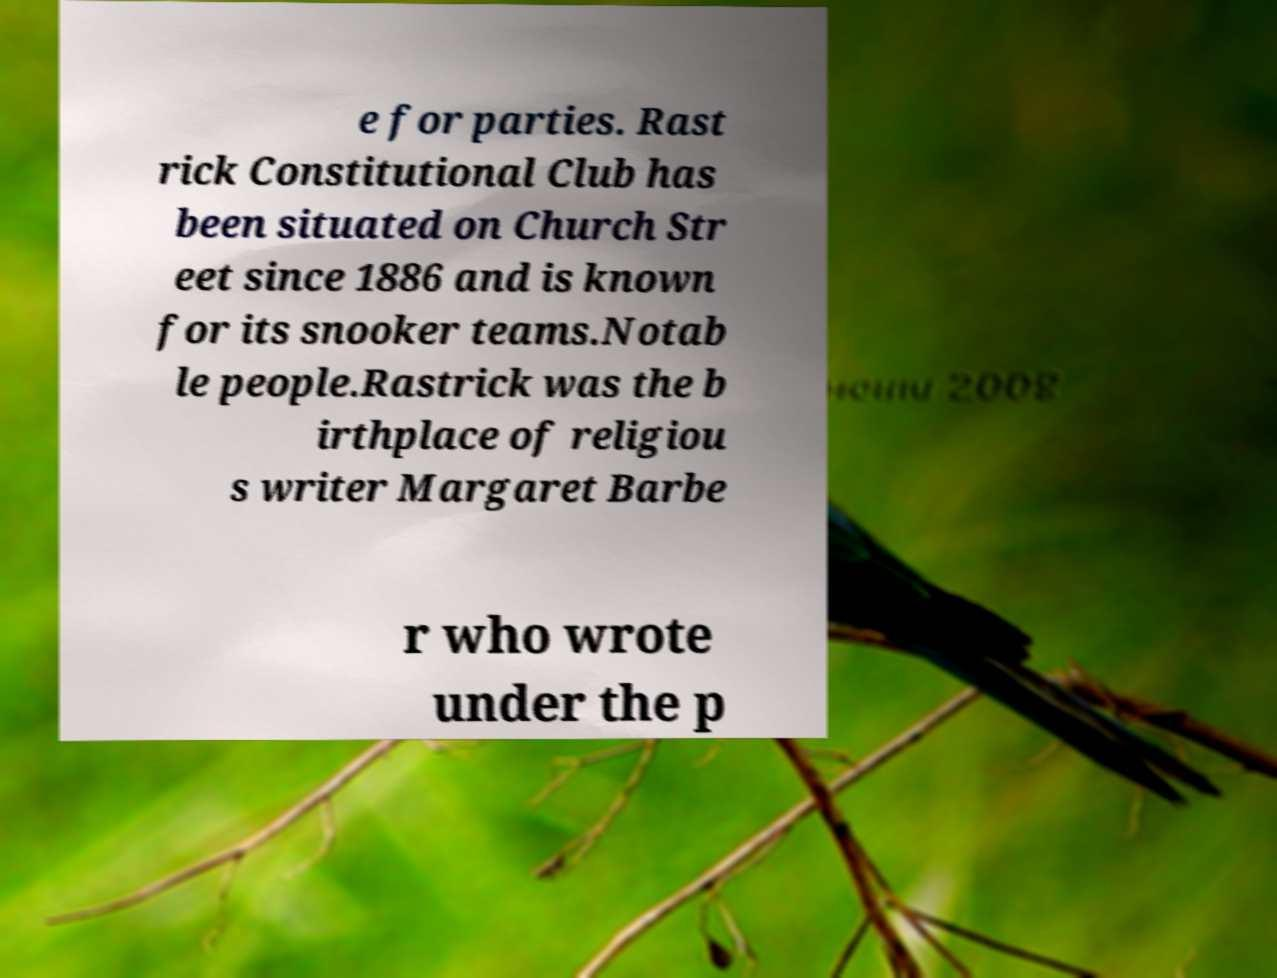Could you extract and type out the text from this image? e for parties. Rast rick Constitutional Club has been situated on Church Str eet since 1886 and is known for its snooker teams.Notab le people.Rastrick was the b irthplace of religiou s writer Margaret Barbe r who wrote under the p 